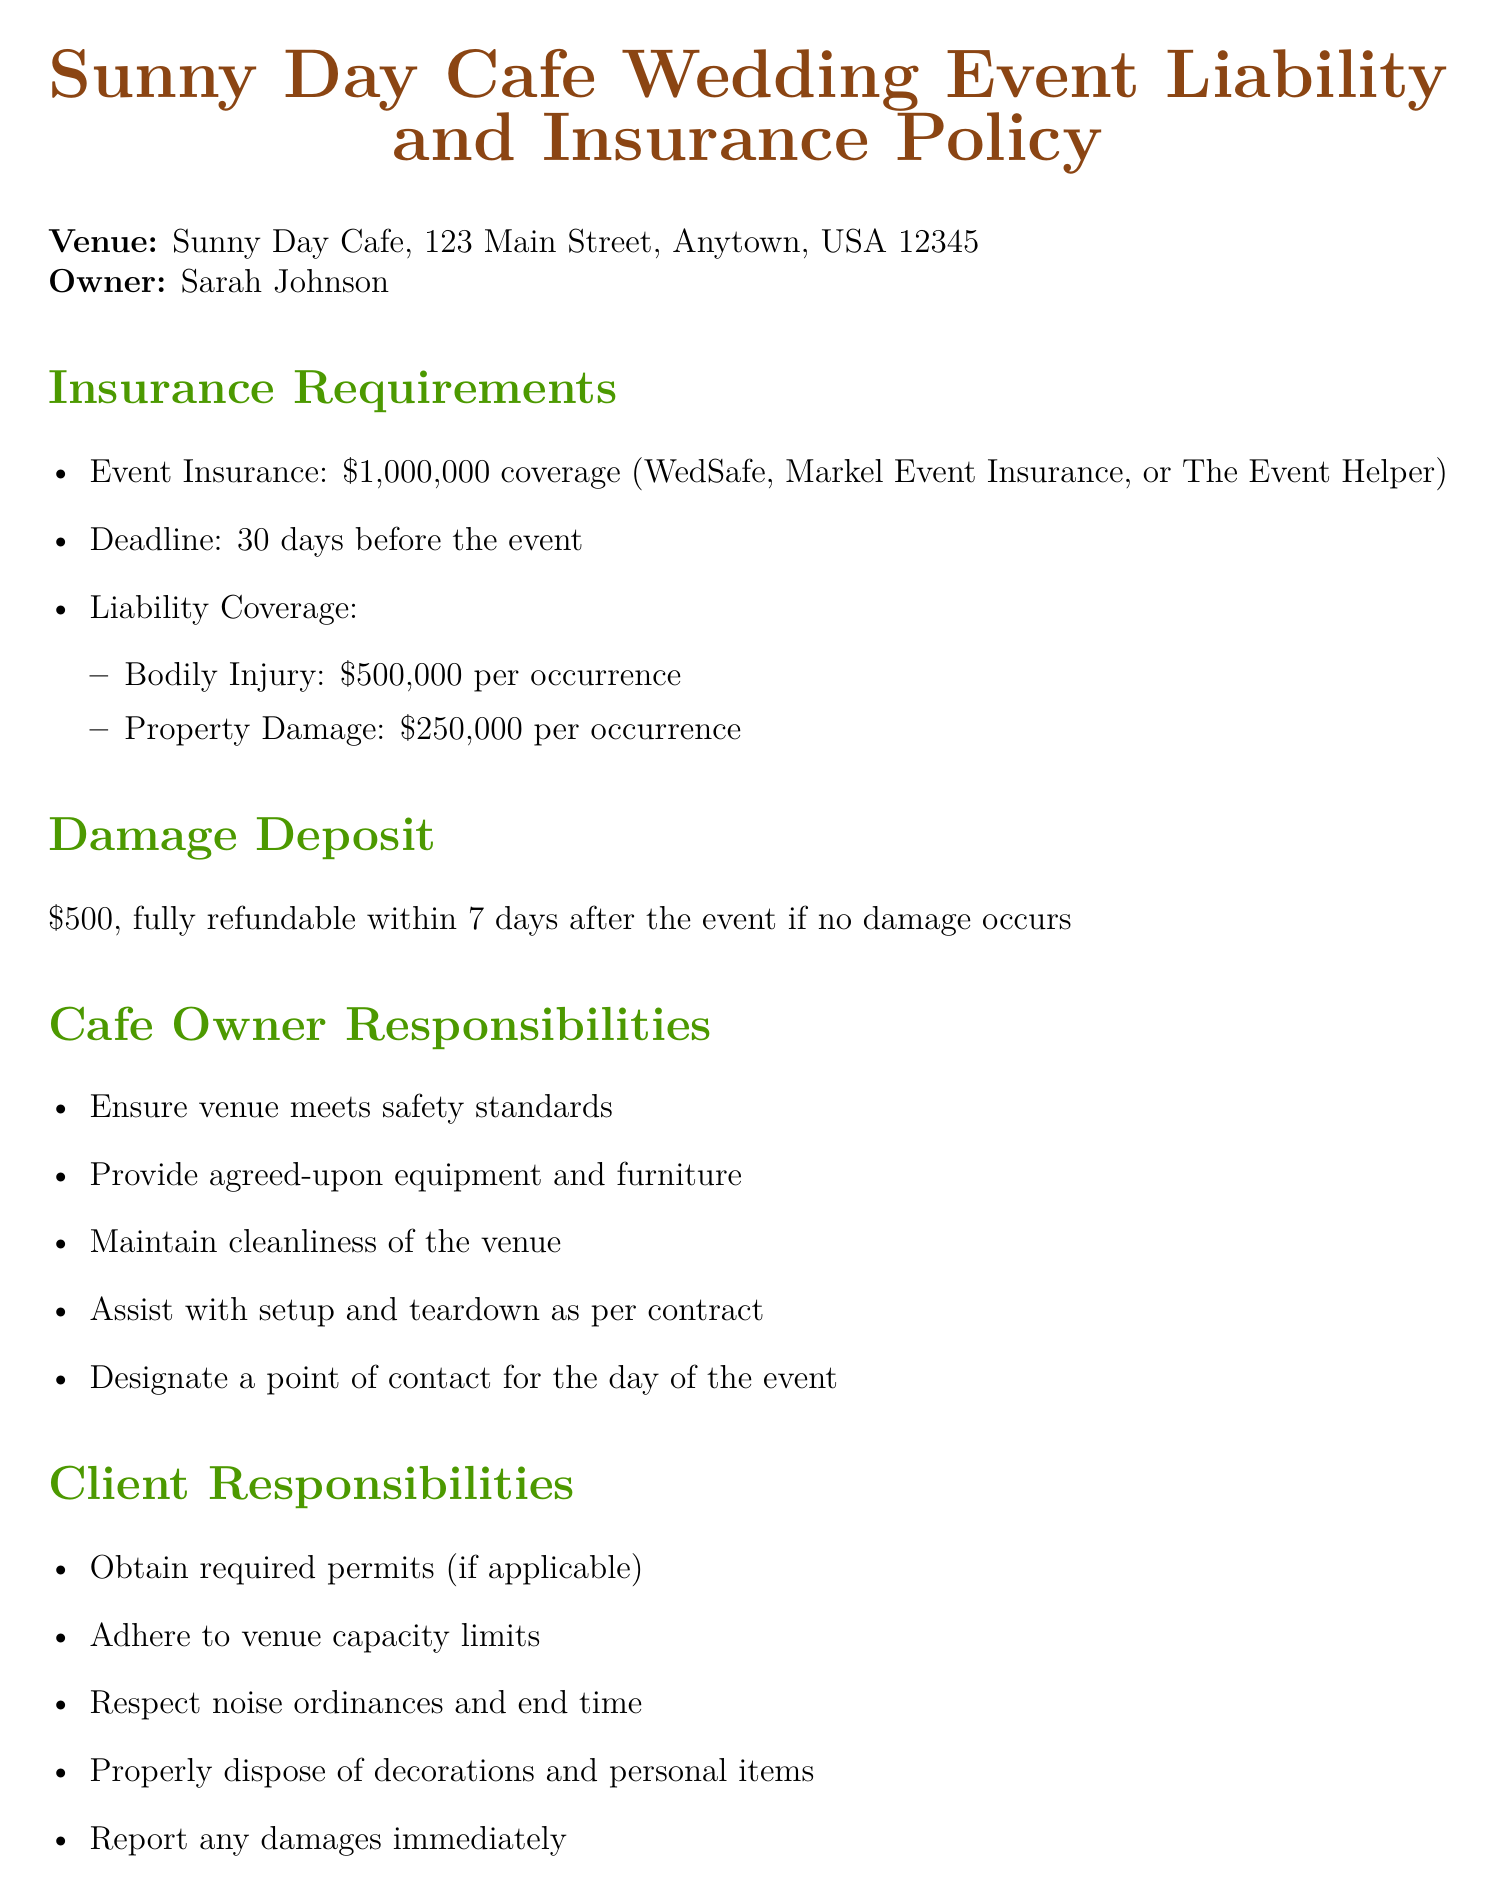What is the required event insurance coverage? The document specifies that the required event insurance coverage is $1,000,000.
Answer: $1,000,000 What is the damage deposit amount? The document states that the damage deposit amount is $500.
Answer: $500 How many days before the event is insurance required? The document indicates that insurance is required 30 days before the event.
Answer: 30 days What is the refund policy for a cancellation with a notice period of 60-89 days? According to the document, the refund policy for this notice period is a 50% refund of total fees paid.
Answer: 50% refund of total fees paid What must the cafe owner ensure regarding the venue? The document mentions that the cafe owner must ensure the venue meets safety standards.
Answer: Safety standards Who needs to report damages immediately? The document states that it is the client's responsibility to report any damages immediately.
Answer: Client What is the last call time for alcohol service? The document specifies that the last call is 30 minutes before the event end time.
Answer: 30 minutes before event end time What is the administrative fee for a full refund cancellation? The document lists the administrative fee as $100 for a full refund cancellation.
Answer: $100 Which companies are suggested for event insurance? The document suggests WedSafe, Markel Event Insurance, or The Event Helper for event insurance.
Answer: WedSafe, Markel Event Insurance, or The Event Helper 